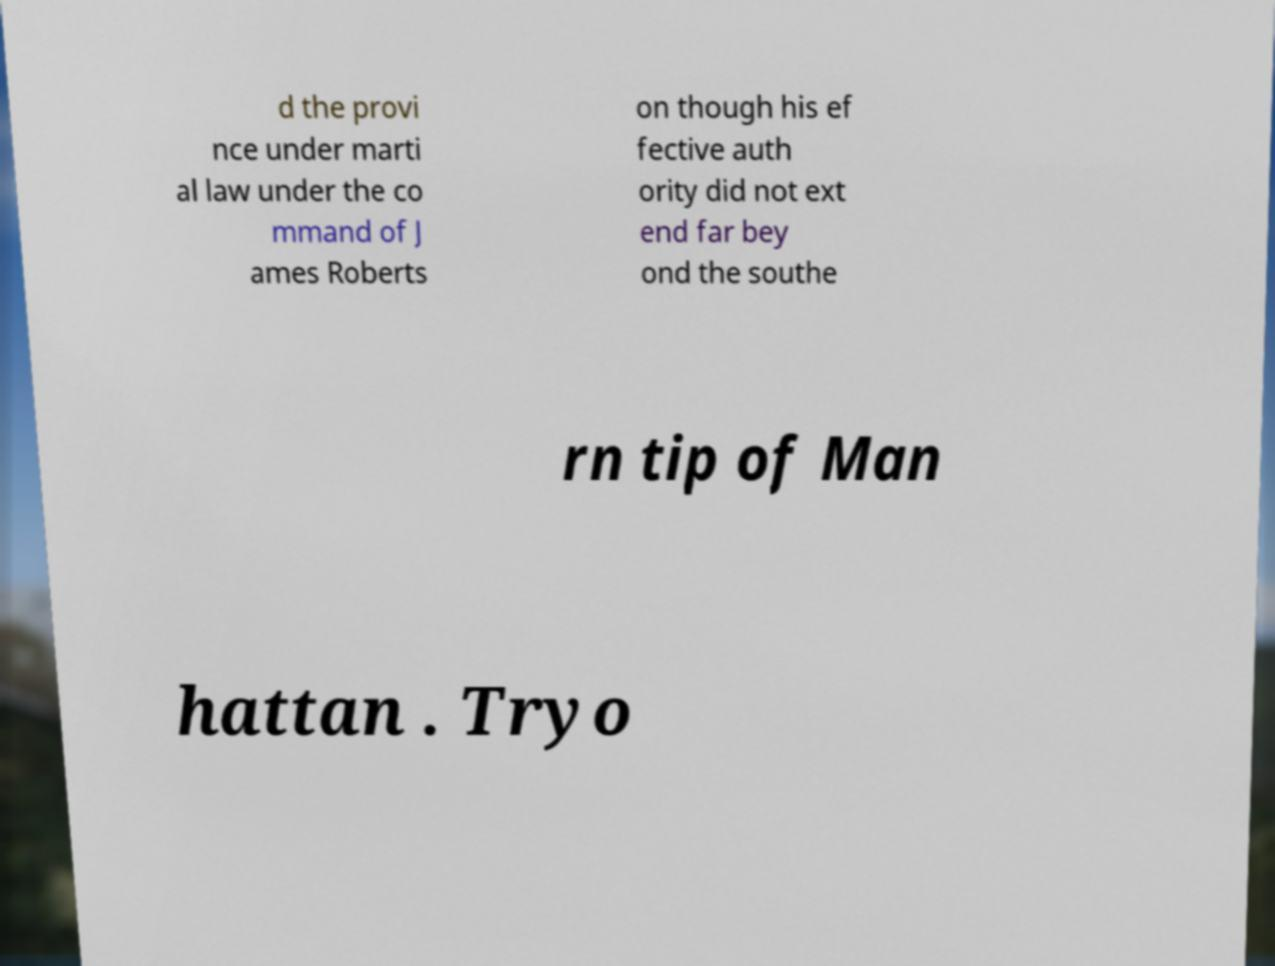Please identify and transcribe the text found in this image. d the provi nce under marti al law under the co mmand of J ames Roberts on though his ef fective auth ority did not ext end far bey ond the southe rn tip of Man hattan . Tryo 